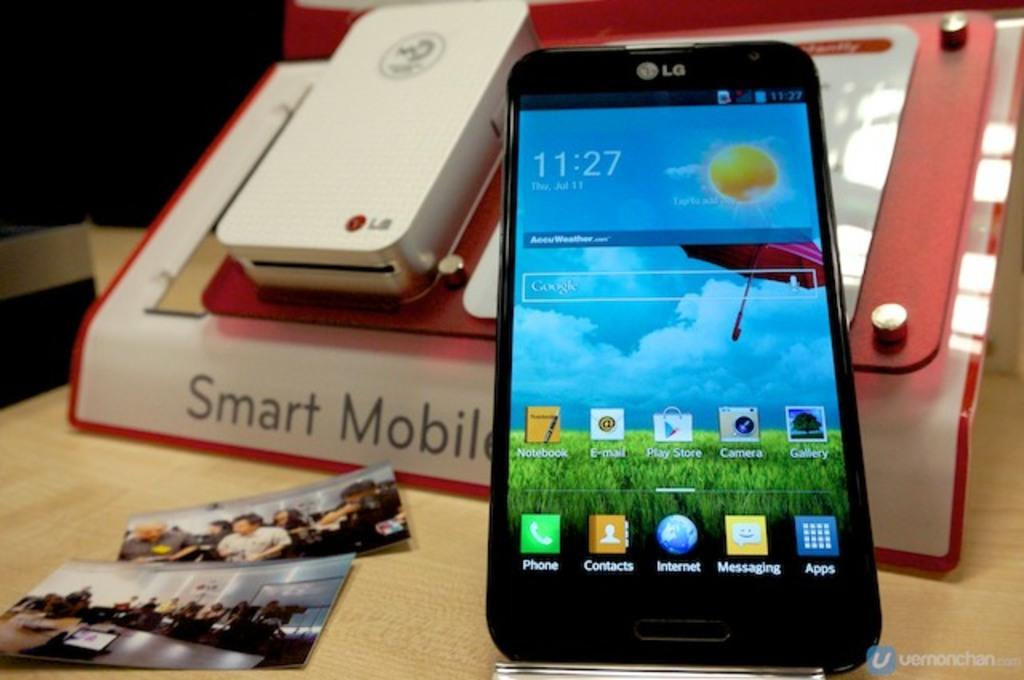<image>
Present a compact description of the photo's key features. An LG cell phone with the home screen displayed laying on a notebook that says Smart Mobile on it. 